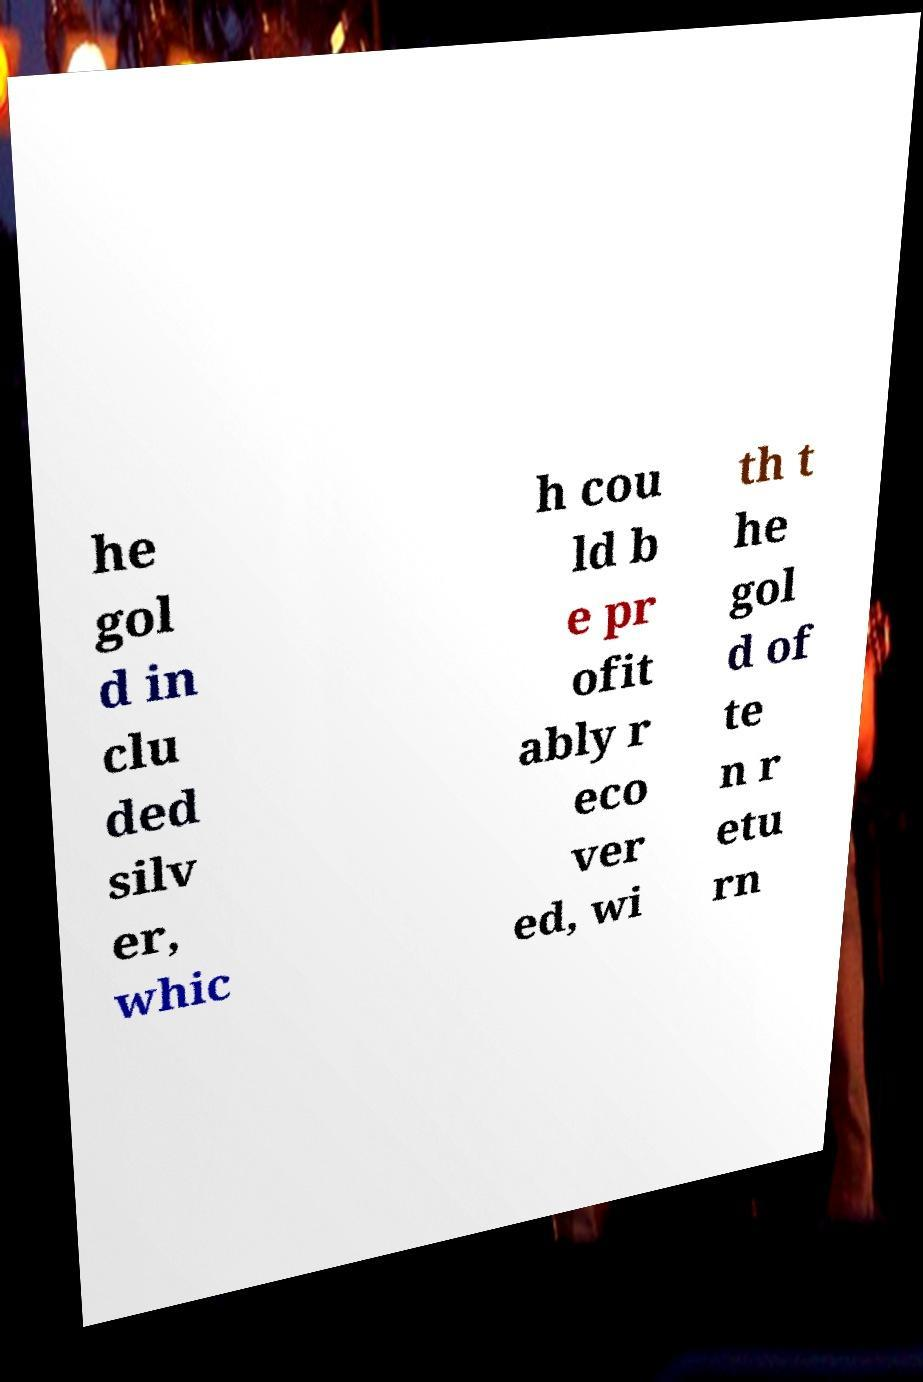For documentation purposes, I need the text within this image transcribed. Could you provide that? he gol d in clu ded silv er, whic h cou ld b e pr ofit ably r eco ver ed, wi th t he gol d of te n r etu rn 